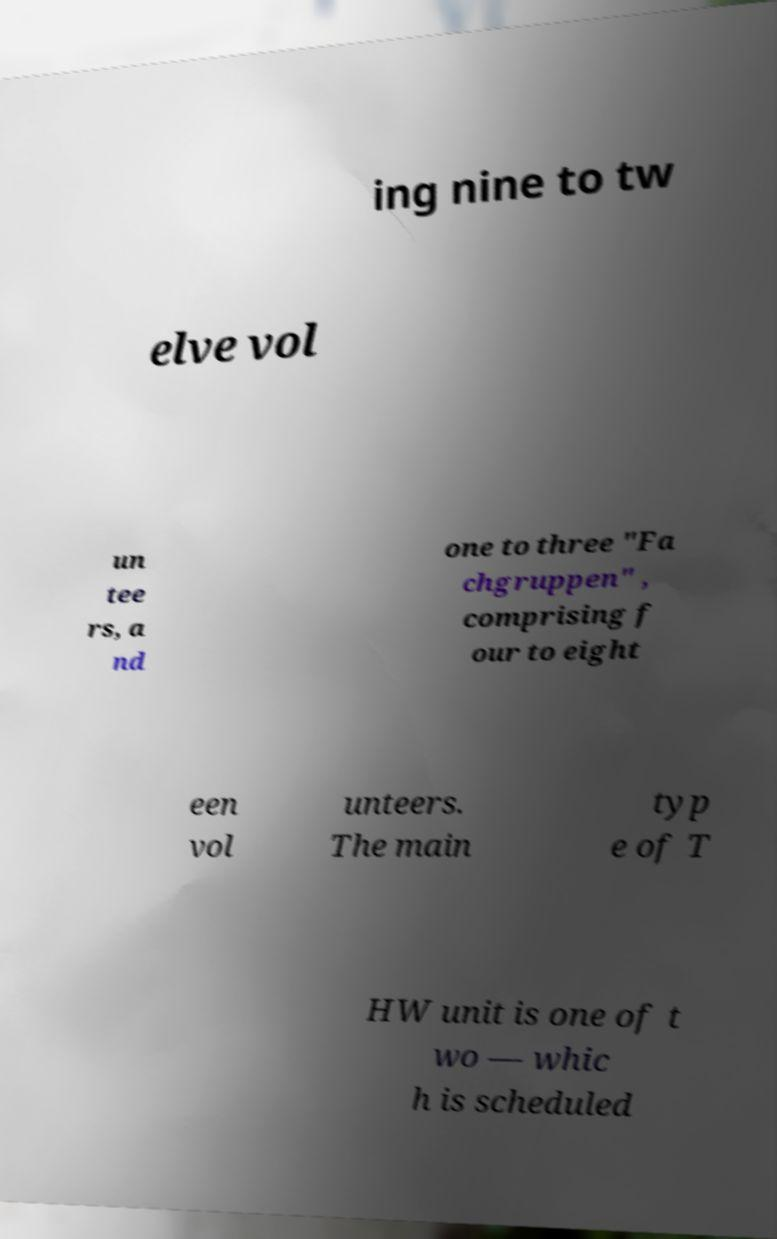What messages or text are displayed in this image? I need them in a readable, typed format. ing nine to tw elve vol un tee rs, a nd one to three "Fa chgruppen" , comprising f our to eight een vol unteers. The main typ e of T HW unit is one of t wo — whic h is scheduled 